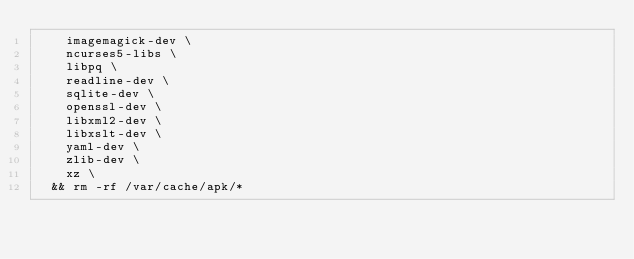<code> <loc_0><loc_0><loc_500><loc_500><_Dockerfile_>		imagemagick-dev \
		ncurses5-libs \
		libpq \
		readline-dev \
		sqlite-dev \
		openssl-dev \
		libxml2-dev \
		libxslt-dev \
		yaml-dev \
		zlib-dev \
		xz \
	&& rm -rf /var/cache/apk/*
</code> 